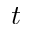Convert formula to latex. <formula><loc_0><loc_0><loc_500><loc_500>t</formula> 